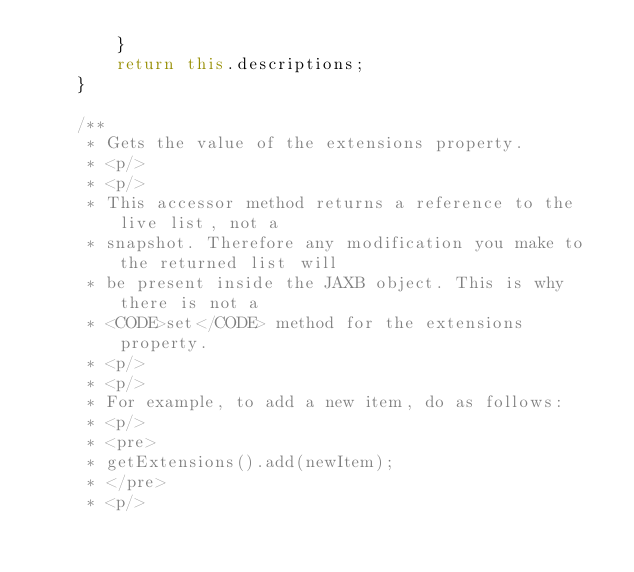Convert code to text. <code><loc_0><loc_0><loc_500><loc_500><_Java_>        }
        return this.descriptions;
    }

    /**
     * Gets the value of the extensions property.
     * <p/>
     * <p/>
     * This accessor method returns a reference to the live list, not a
     * snapshot. Therefore any modification you make to the returned list will
     * be present inside the JAXB object. This is why there is not a
     * <CODE>set</CODE> method for the extensions property.
     * <p/>
     * <p/>
     * For example, to add a new item, do as follows:
     * <p/>
     * <pre>
     * getExtensions().add(newItem);
     * </pre>
     * <p/></code> 